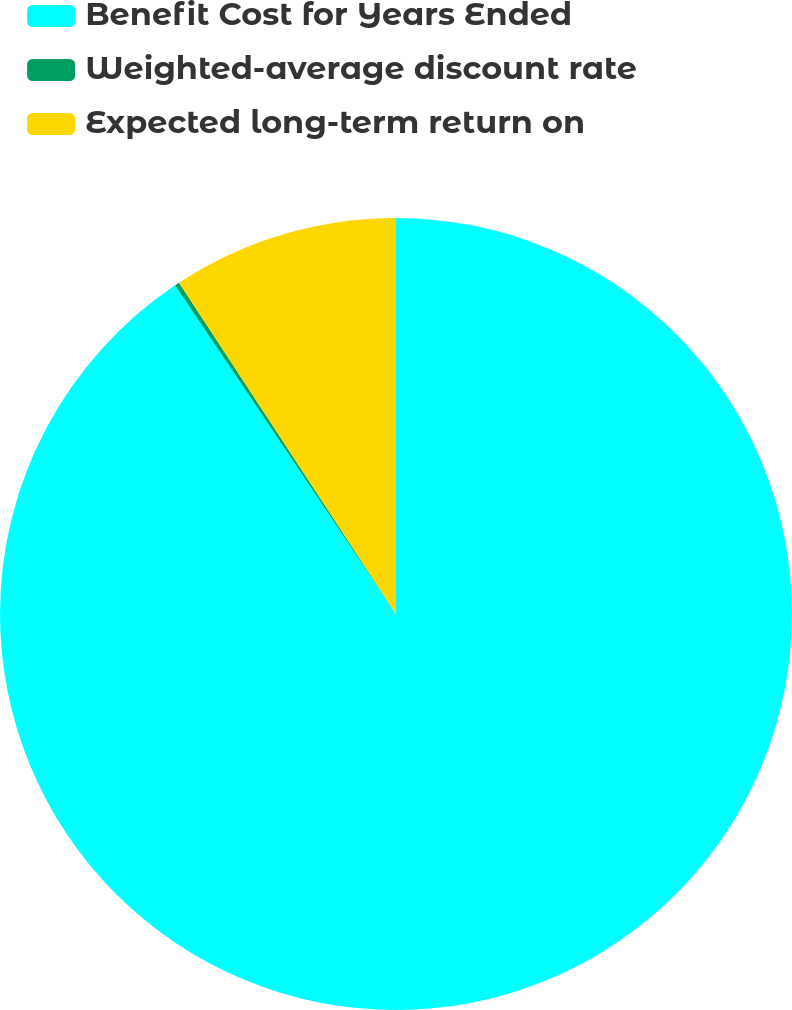Convert chart. <chart><loc_0><loc_0><loc_500><loc_500><pie_chart><fcel>Benefit Cost for Years Ended<fcel>Weighted-average discount rate<fcel>Expected long-term return on<nl><fcel>90.58%<fcel>0.19%<fcel>9.23%<nl></chart> 